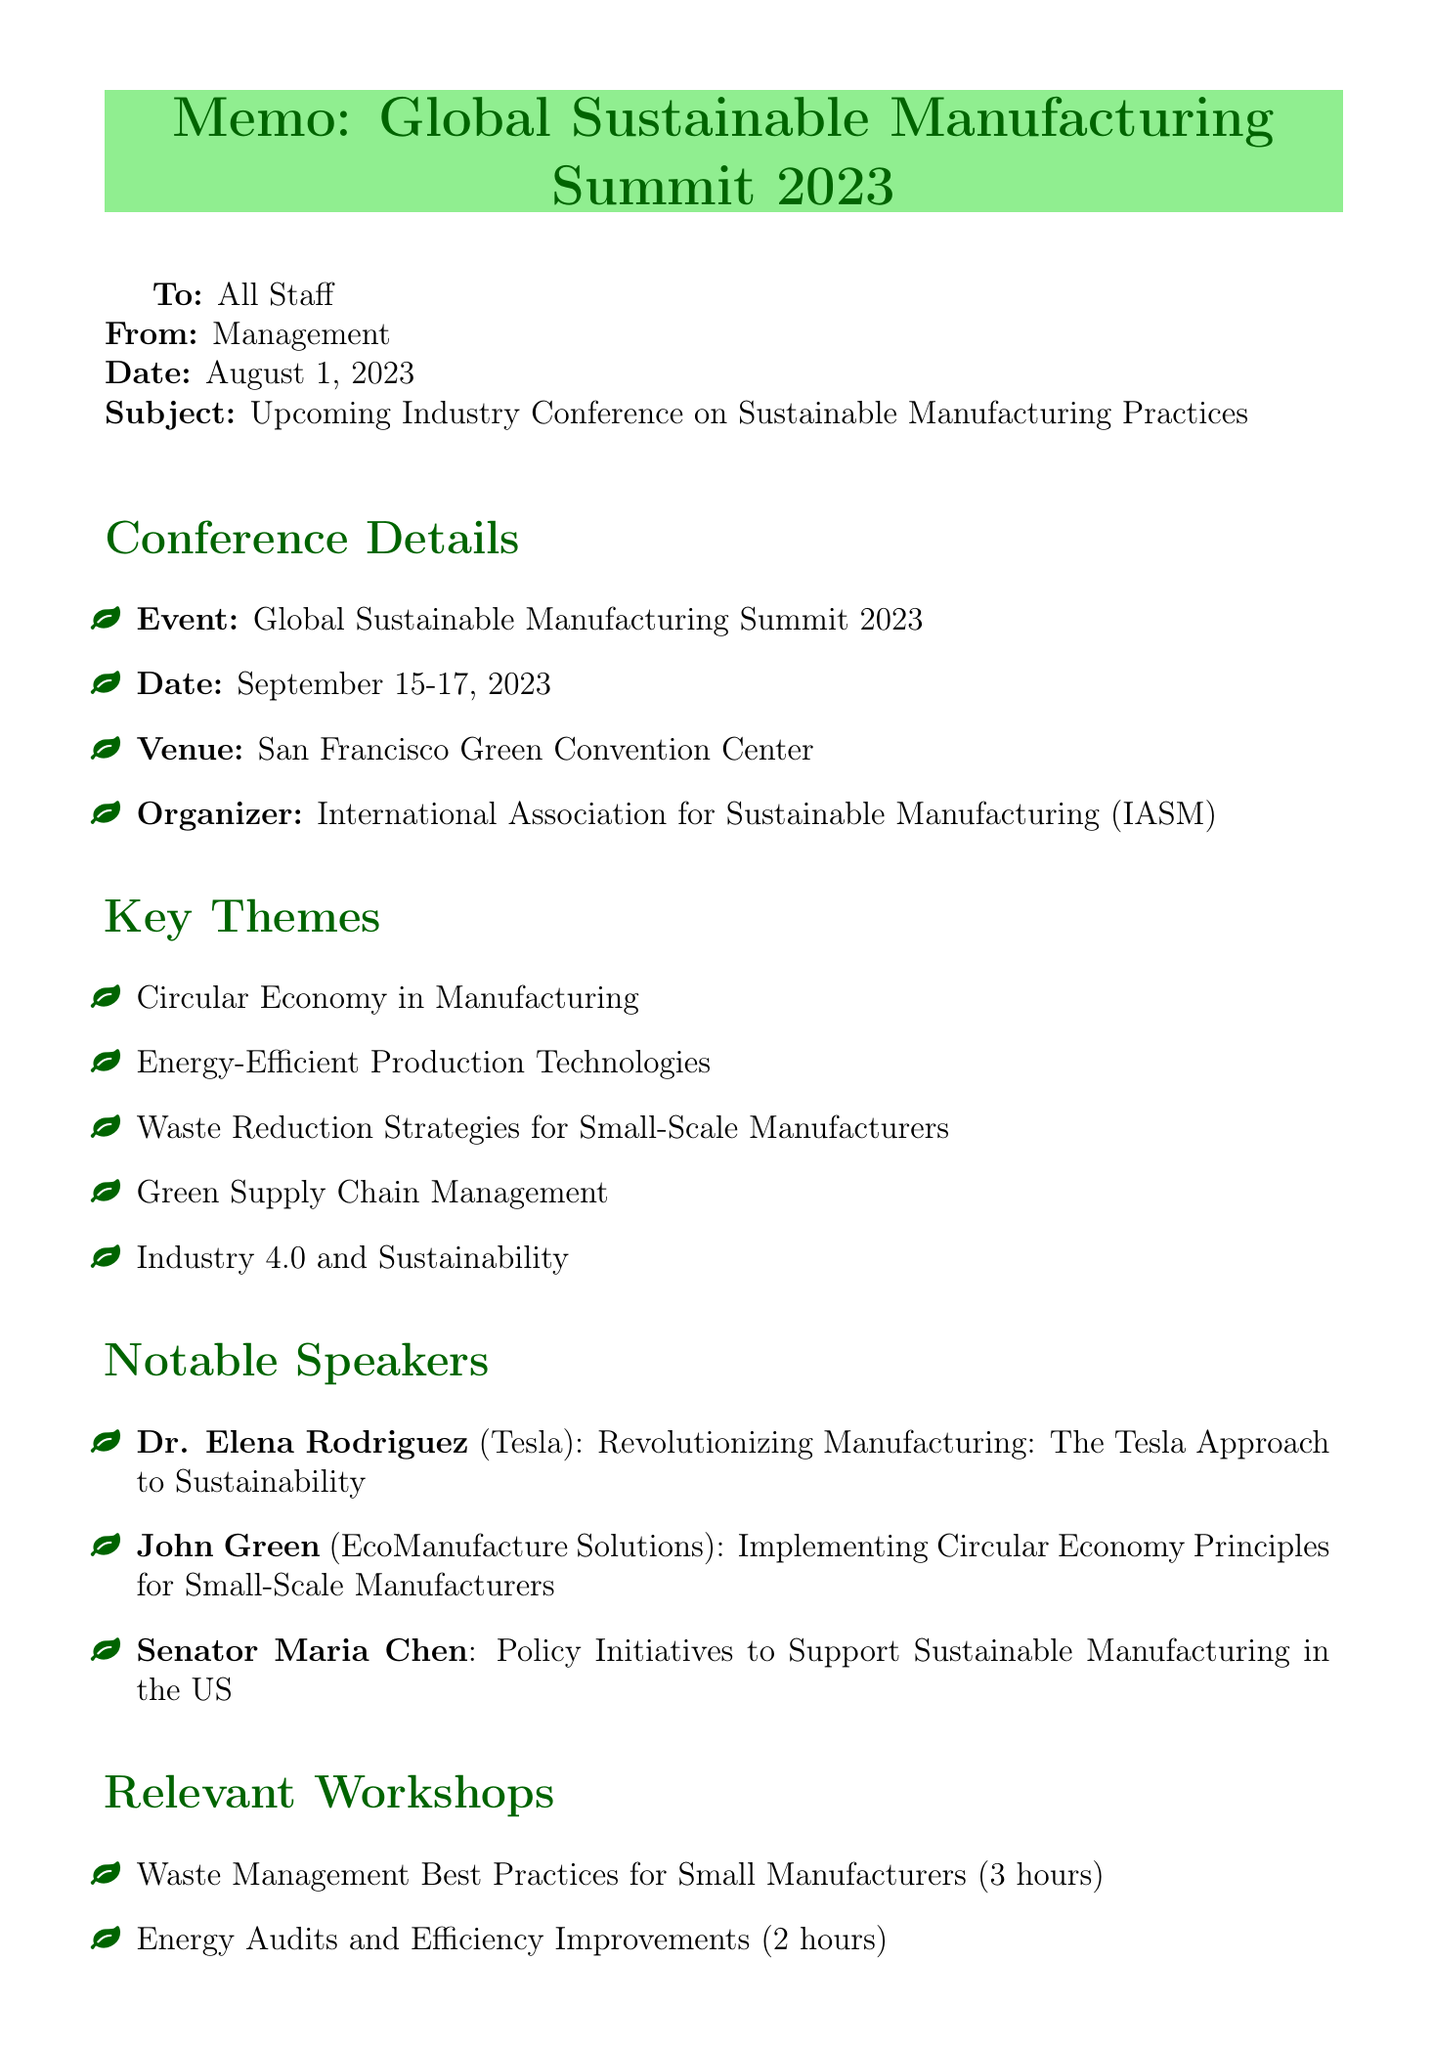What is the name of the conference? The name of the conference is explicitly mentioned in the document as "Global Sustainable Manufacturing Summit 2023."
Answer: Global Sustainable Manufacturing Summit 2023 What are the dates of the conference? The document specifies the dates of the conference as September 15-17, 2023.
Answer: September 15-17, 2023 Who is facilitating the workshop on waste management? The facilitator for the waste management workshop is detailed in the document as Sarah Johnson, Waste Management Specialist, EPA.
Answer: Sarah Johnson What topic will Dr. Elena Rodriguez discuss? The document outlines that Dr. Elena Rodriguez will discuss "Revolutionizing Manufacturing: The Tesla Approach to Sustainability."
Answer: Revolutionizing Manufacturing: The Tesla Approach to Sustainability What is one of the key themes at the conference? The document lists several key themes, one of which is "Waste Reduction Strategies for Small-Scale Manufacturers."
Answer: Waste Reduction Strategies for Small-Scale Manufacturers What is the duration of the energy audits workshop? According to the document, the duration of the energy audits workshop is stated as 2 hours.
Answer: 2 hours What type of opportunities are included for networking? The document describes various networking opportunities, one of which is the "Sustainable Suppliers Expo."
Answer: Sustainable Suppliers Expo How long is the waste management workshop? The document indicates that the waste management workshop is 3 hours long.
Answer: 3 hours What is one expected outcome of attending the conference? The document provides several expected outcomes, including gaining insights on cost-effective sustainable practices.
Answer: Gain insights on cost-effective sustainable practices 